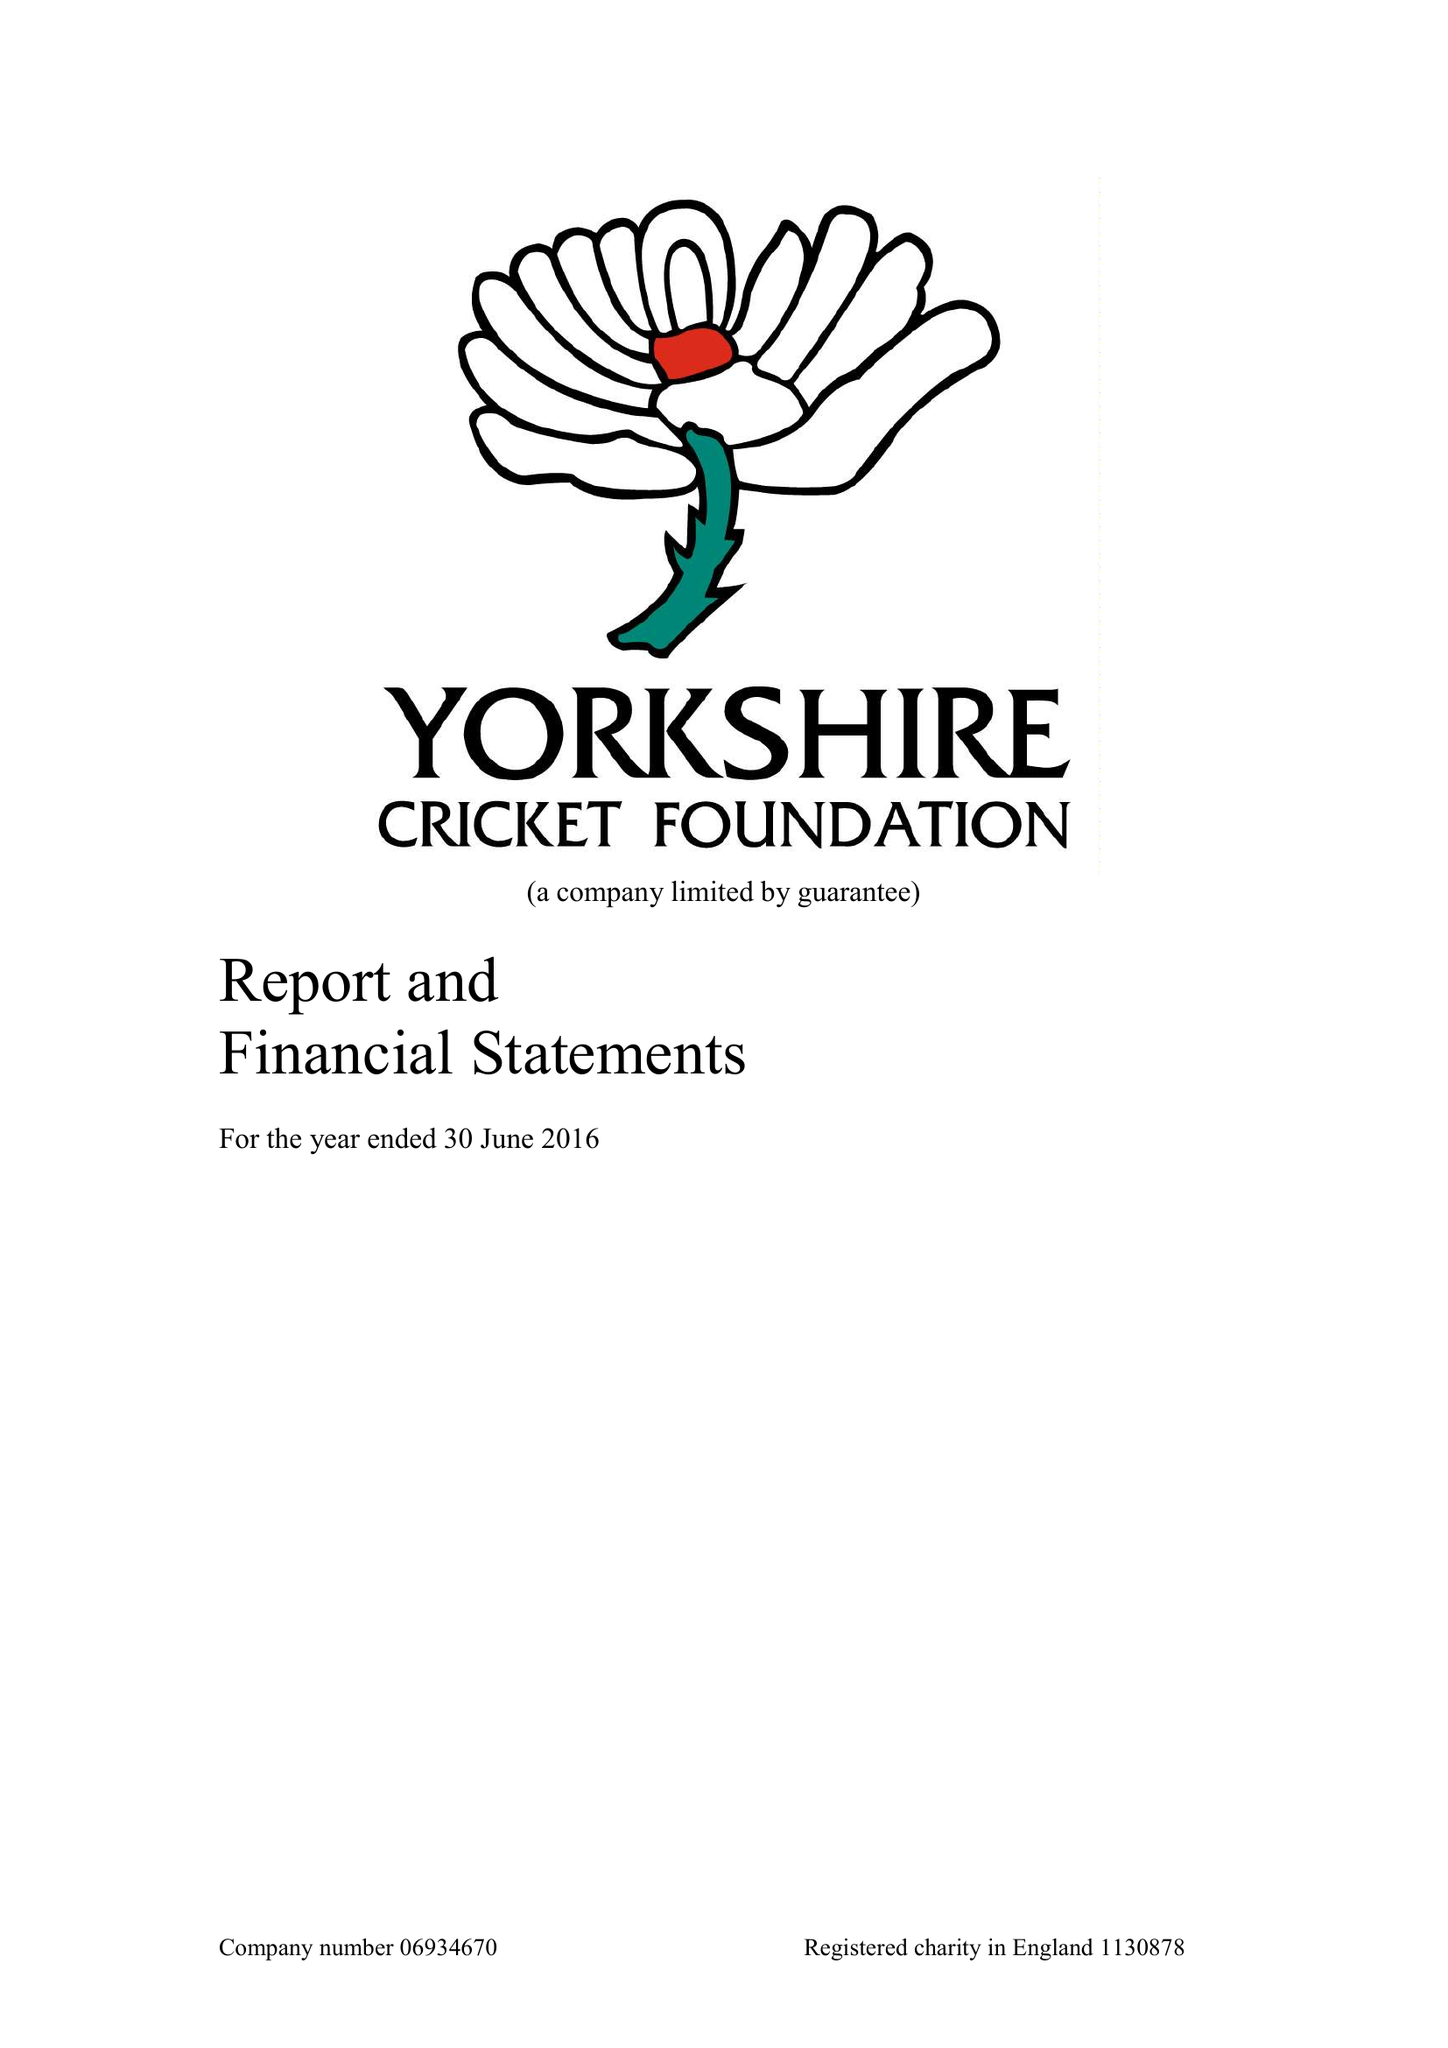What is the value for the income_annually_in_british_pounds?
Answer the question using a single word or phrase. 359742.00 